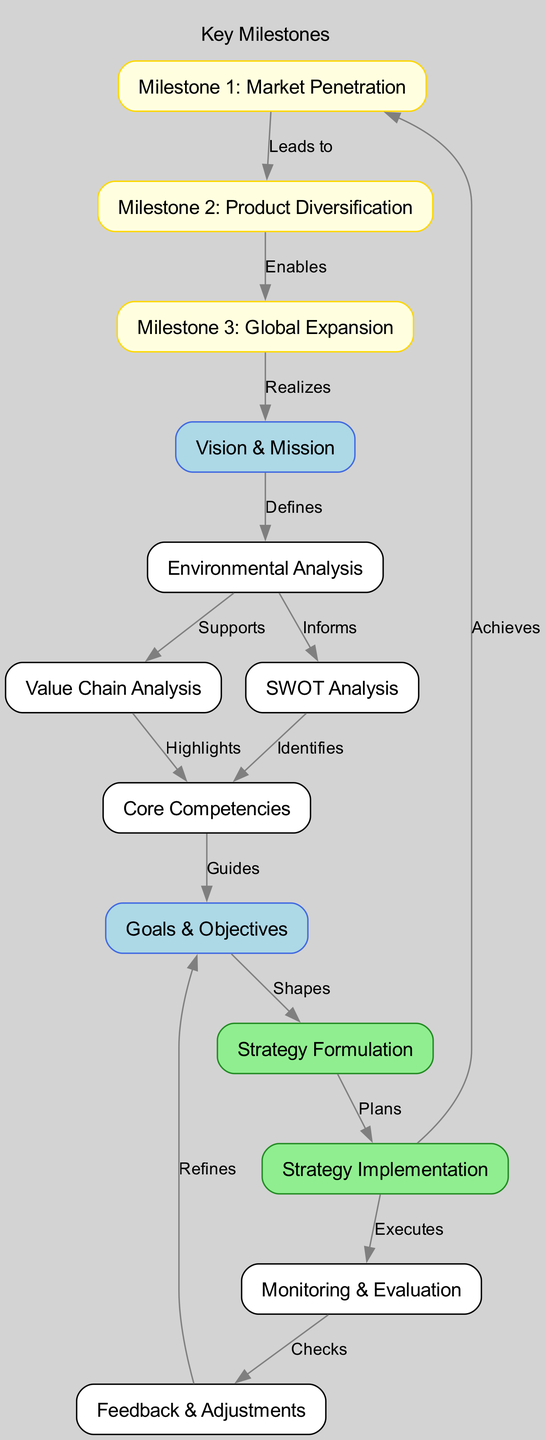What is the first node in the diagram? The first node in the diagram is "Vision & Mission," which initiates the strategic planning process.
Answer: Vision & Mission How many key milestones are listed in the diagram? There are three key milestones: Market Penetration, Product Diversification, and Global Expansion.
Answer: 3 What type of relationship exists between "Goals & Objectives" and "Strategy Formulation"? The relationship between "Goals & Objectives" and "Strategy Formulation" is that "Goals & Objectives" shapes the strategy formulation process.
Answer: Shapes Which node follows "Strategy Implementation" in the flow? The node that follows "Strategy Implementation" in the flow is "Monitoring & Evaluation," which leads to assessing the execution of the strategy.
Answer: Monitoring & Evaluation What does "SWOT Analysis" identify in the process? "SWOT Analysis" identifies core competencies, which are essential for defining strengths and weaknesses relative to market opportunities and threats.
Answer: Core Competencies Which milestone leads to "Product Diversification"? "Milestone 1: Market Penetration" leads to "Milestone 2: Product Diversification," indicating a sequential progression in strategic goals.
Answer: Milestone 1: Market Penetration What role does the "Feedback & Adjustments" node play in the process? The "Feedback & Adjustments" node refines the "Goals & Objectives," allowing for an iterative approach to the strategic planning process based on evaluation.
Answer: Refines How does "Milestone 3: Global Expansion" relate to the "Vision & Mission"? "Milestone 3: Global Expansion" realizes the "Vision & Mission," indicating that achieving this milestone is aligned with fulfilling the overarching corporate vision.
Answer: Realizes 